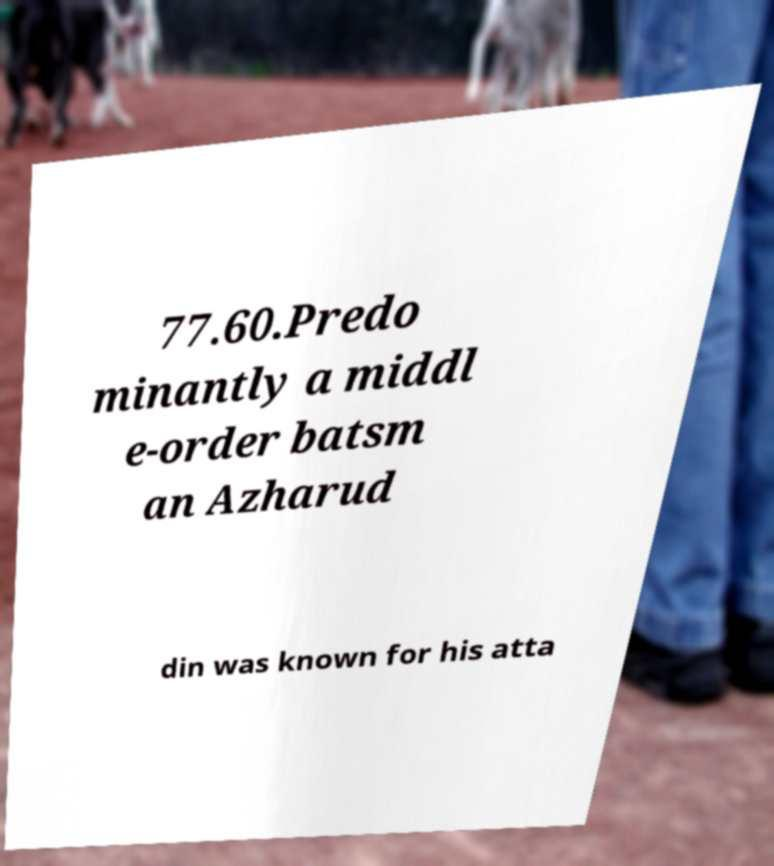Could you assist in decoding the text presented in this image and type it out clearly? 77.60.Predo minantly a middl e-order batsm an Azharud din was known for his atta 